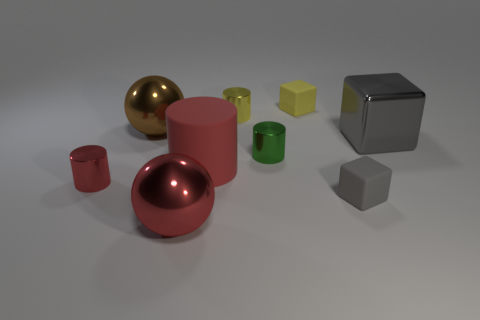Subtract all red cylinders. How many were subtracted if there are1red cylinders left? 1 Subtract all rubber cylinders. How many cylinders are left? 3 Subtract 0 purple cylinders. How many objects are left? 9 Subtract all spheres. How many objects are left? 7 Subtract 2 balls. How many balls are left? 0 Subtract all red balls. Subtract all gray cylinders. How many balls are left? 1 Subtract all red blocks. How many gray spheres are left? 0 Subtract all tiny gray blocks. Subtract all balls. How many objects are left? 6 Add 2 yellow blocks. How many yellow blocks are left? 3 Add 4 small gray metallic things. How many small gray metallic things exist? 4 